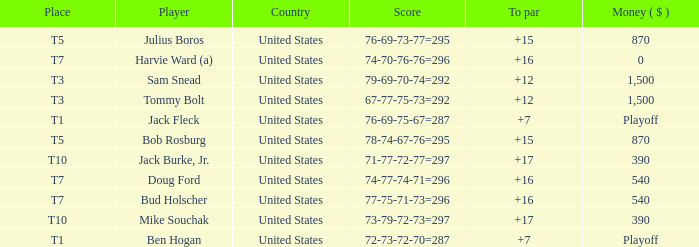What is average to par when Bud Holscher is the player? 16.0. 